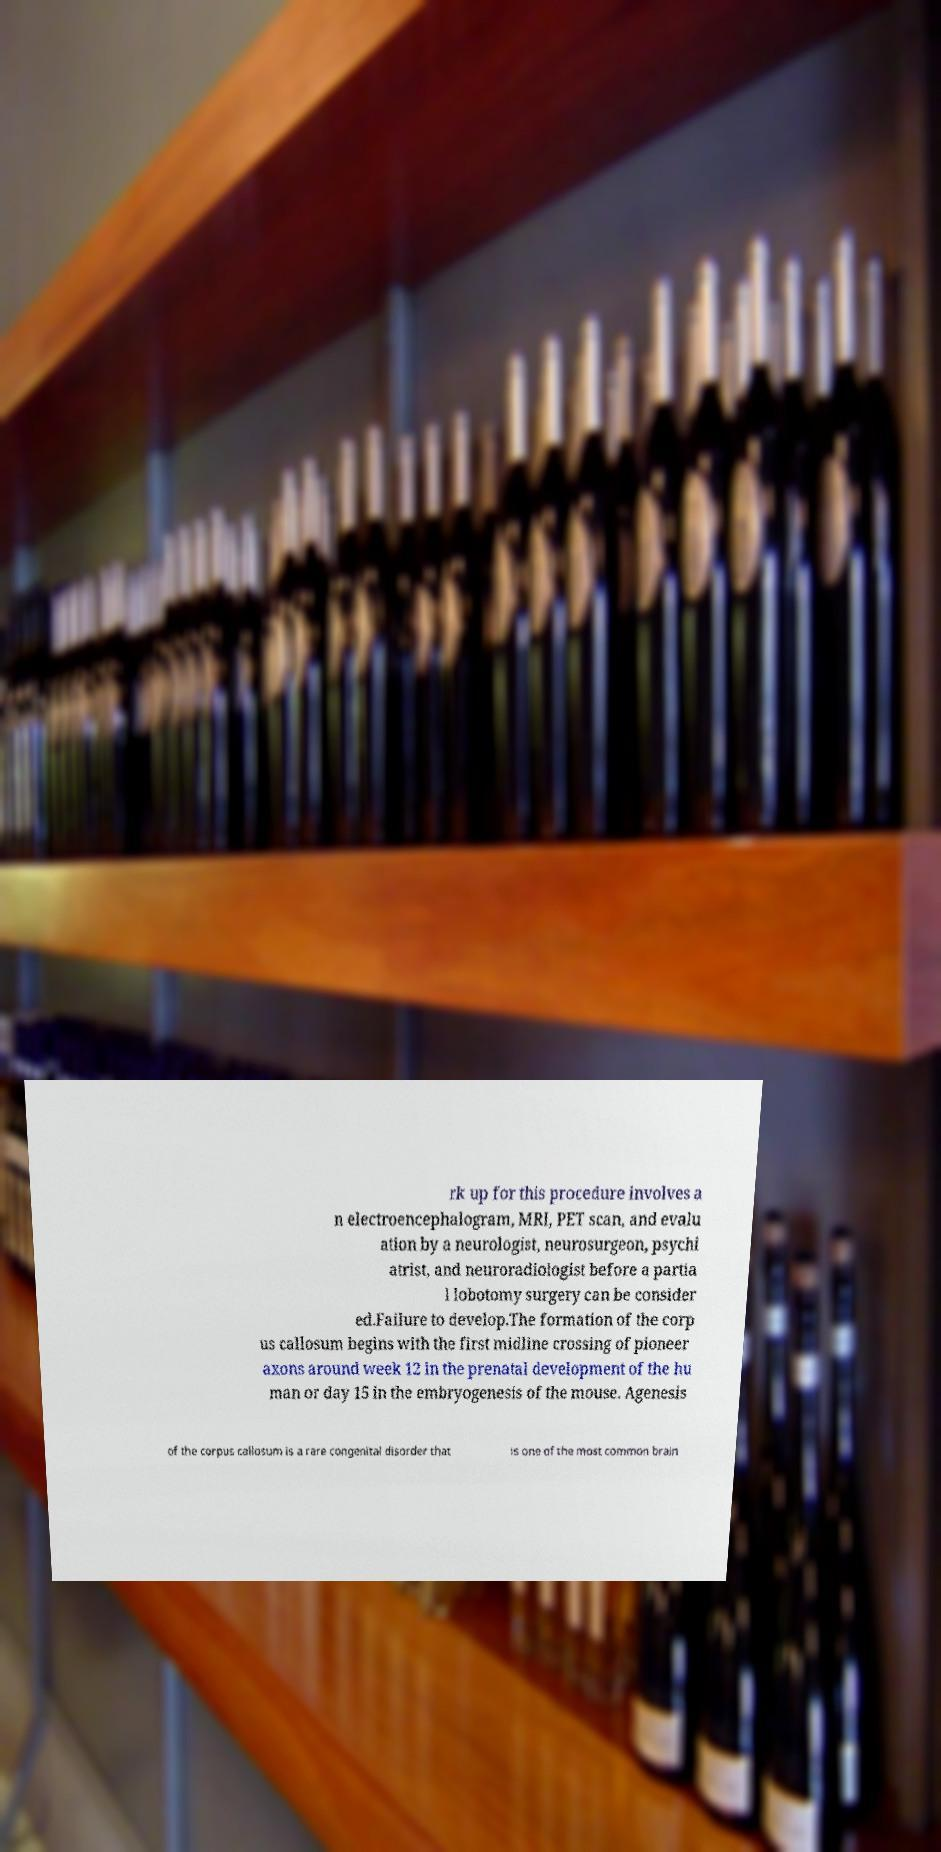Could you assist in decoding the text presented in this image and type it out clearly? rk up for this procedure involves a n electroencephalogram, MRI, PET scan, and evalu ation by a neurologist, neurosurgeon, psychi atrist, and neuroradiologist before a partia l lobotomy surgery can be consider ed.Failure to develop.The formation of the corp us callosum begins with the first midline crossing of pioneer axons around week 12 in the prenatal development of the hu man or day 15 in the embryogenesis of the mouse. Agenesis of the corpus callosum is a rare congenital disorder that is one of the most common brain 